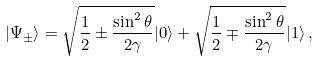Convert formula to latex. <formula><loc_0><loc_0><loc_500><loc_500>| \Psi _ { \pm } \rangle = \sqrt { \frac { 1 } { 2 } \pm \frac { \sin ^ { 2 } { \theta } } { 2 \gamma } } | 0 \rangle + \sqrt { \frac { 1 } { 2 } \mp \frac { \sin ^ { 2 } { \theta } } { 2 \gamma } } | 1 \rangle \, ,</formula> 